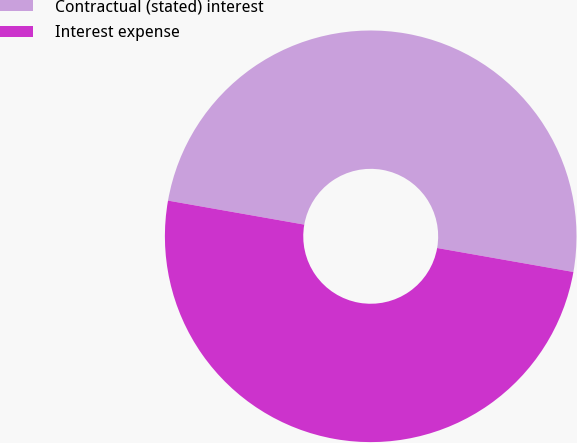Convert chart to OTSL. <chart><loc_0><loc_0><loc_500><loc_500><pie_chart><fcel>Contractual (stated) interest<fcel>Interest expense<nl><fcel>50.0%<fcel>50.0%<nl></chart> 